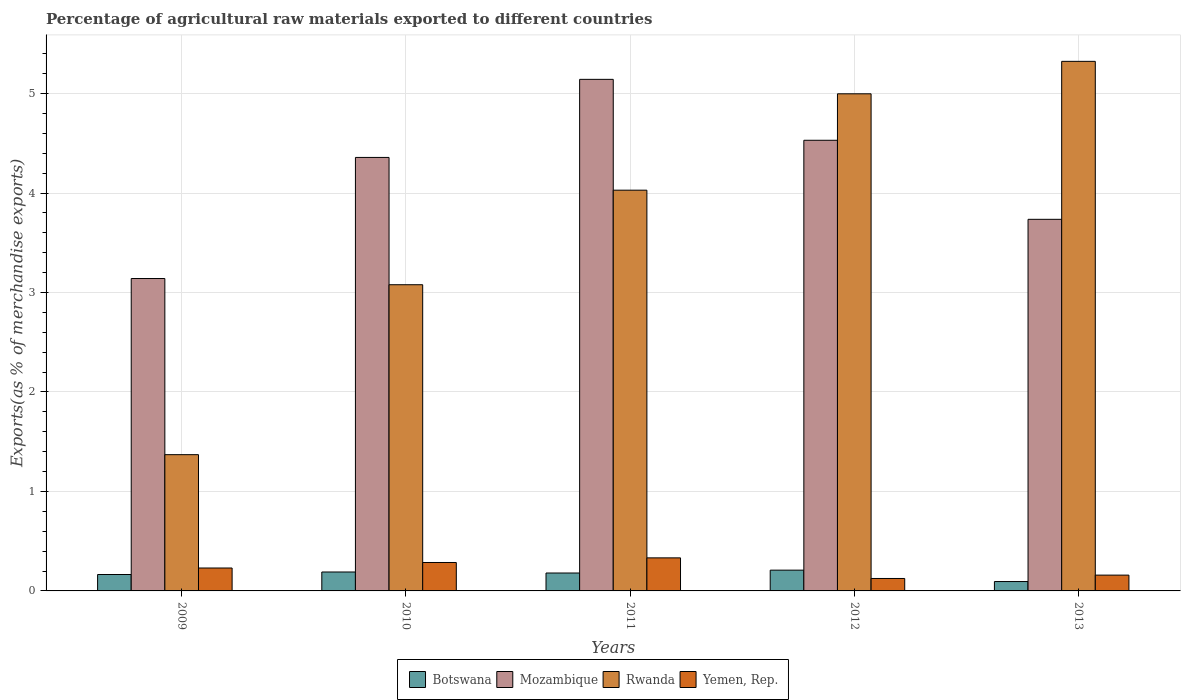Are the number of bars per tick equal to the number of legend labels?
Your answer should be very brief. Yes. Are the number of bars on each tick of the X-axis equal?
Offer a very short reply. Yes. How many bars are there on the 4th tick from the right?
Offer a very short reply. 4. What is the percentage of exports to different countries in Rwanda in 2013?
Give a very brief answer. 5.32. Across all years, what is the maximum percentage of exports to different countries in Botswana?
Offer a very short reply. 0.21. Across all years, what is the minimum percentage of exports to different countries in Botswana?
Make the answer very short. 0.09. In which year was the percentage of exports to different countries in Yemen, Rep. minimum?
Keep it short and to the point. 2012. What is the total percentage of exports to different countries in Mozambique in the graph?
Provide a succinct answer. 20.91. What is the difference between the percentage of exports to different countries in Yemen, Rep. in 2009 and that in 2013?
Offer a terse response. 0.07. What is the difference between the percentage of exports to different countries in Botswana in 2011 and the percentage of exports to different countries in Mozambique in 2012?
Provide a short and direct response. -4.35. What is the average percentage of exports to different countries in Botswana per year?
Your response must be concise. 0.17. In the year 2009, what is the difference between the percentage of exports to different countries in Yemen, Rep. and percentage of exports to different countries in Botswana?
Offer a terse response. 0.07. In how many years, is the percentage of exports to different countries in Mozambique greater than 3.8 %?
Provide a succinct answer. 3. What is the ratio of the percentage of exports to different countries in Mozambique in 2009 to that in 2010?
Offer a very short reply. 0.72. Is the difference between the percentage of exports to different countries in Yemen, Rep. in 2010 and 2011 greater than the difference between the percentage of exports to different countries in Botswana in 2010 and 2011?
Ensure brevity in your answer.  No. What is the difference between the highest and the second highest percentage of exports to different countries in Botswana?
Provide a short and direct response. 0.02. What is the difference between the highest and the lowest percentage of exports to different countries in Yemen, Rep.?
Offer a terse response. 0.21. In how many years, is the percentage of exports to different countries in Rwanda greater than the average percentage of exports to different countries in Rwanda taken over all years?
Provide a succinct answer. 3. Is it the case that in every year, the sum of the percentage of exports to different countries in Rwanda and percentage of exports to different countries in Mozambique is greater than the sum of percentage of exports to different countries in Yemen, Rep. and percentage of exports to different countries in Botswana?
Your answer should be compact. Yes. What does the 3rd bar from the left in 2009 represents?
Your answer should be very brief. Rwanda. What does the 3rd bar from the right in 2009 represents?
Offer a terse response. Mozambique. How many bars are there?
Give a very brief answer. 20. How many years are there in the graph?
Ensure brevity in your answer.  5. What is the difference between two consecutive major ticks on the Y-axis?
Provide a succinct answer. 1. Are the values on the major ticks of Y-axis written in scientific E-notation?
Offer a terse response. No. Does the graph contain any zero values?
Make the answer very short. No. Where does the legend appear in the graph?
Give a very brief answer. Bottom center. How many legend labels are there?
Your response must be concise. 4. How are the legend labels stacked?
Give a very brief answer. Horizontal. What is the title of the graph?
Your answer should be compact. Percentage of agricultural raw materials exported to different countries. Does "Tonga" appear as one of the legend labels in the graph?
Provide a short and direct response. No. What is the label or title of the X-axis?
Give a very brief answer. Years. What is the label or title of the Y-axis?
Offer a terse response. Exports(as % of merchandise exports). What is the Exports(as % of merchandise exports) of Botswana in 2009?
Provide a succinct answer. 0.17. What is the Exports(as % of merchandise exports) in Mozambique in 2009?
Provide a short and direct response. 3.14. What is the Exports(as % of merchandise exports) of Rwanda in 2009?
Your response must be concise. 1.37. What is the Exports(as % of merchandise exports) in Yemen, Rep. in 2009?
Offer a very short reply. 0.23. What is the Exports(as % of merchandise exports) of Botswana in 2010?
Ensure brevity in your answer.  0.19. What is the Exports(as % of merchandise exports) in Mozambique in 2010?
Provide a succinct answer. 4.36. What is the Exports(as % of merchandise exports) of Rwanda in 2010?
Offer a terse response. 3.08. What is the Exports(as % of merchandise exports) of Yemen, Rep. in 2010?
Provide a succinct answer. 0.29. What is the Exports(as % of merchandise exports) of Botswana in 2011?
Keep it short and to the point. 0.18. What is the Exports(as % of merchandise exports) of Mozambique in 2011?
Provide a short and direct response. 5.14. What is the Exports(as % of merchandise exports) in Rwanda in 2011?
Offer a terse response. 4.03. What is the Exports(as % of merchandise exports) of Yemen, Rep. in 2011?
Provide a succinct answer. 0.33. What is the Exports(as % of merchandise exports) in Botswana in 2012?
Provide a succinct answer. 0.21. What is the Exports(as % of merchandise exports) of Mozambique in 2012?
Ensure brevity in your answer.  4.53. What is the Exports(as % of merchandise exports) of Rwanda in 2012?
Make the answer very short. 5. What is the Exports(as % of merchandise exports) in Yemen, Rep. in 2012?
Make the answer very short. 0.13. What is the Exports(as % of merchandise exports) of Botswana in 2013?
Keep it short and to the point. 0.09. What is the Exports(as % of merchandise exports) in Mozambique in 2013?
Offer a terse response. 3.74. What is the Exports(as % of merchandise exports) in Rwanda in 2013?
Your answer should be compact. 5.32. What is the Exports(as % of merchandise exports) in Yemen, Rep. in 2013?
Provide a succinct answer. 0.16. Across all years, what is the maximum Exports(as % of merchandise exports) in Botswana?
Ensure brevity in your answer.  0.21. Across all years, what is the maximum Exports(as % of merchandise exports) of Mozambique?
Give a very brief answer. 5.14. Across all years, what is the maximum Exports(as % of merchandise exports) of Rwanda?
Provide a succinct answer. 5.32. Across all years, what is the maximum Exports(as % of merchandise exports) of Yemen, Rep.?
Provide a short and direct response. 0.33. Across all years, what is the minimum Exports(as % of merchandise exports) in Botswana?
Give a very brief answer. 0.09. Across all years, what is the minimum Exports(as % of merchandise exports) of Mozambique?
Make the answer very short. 3.14. Across all years, what is the minimum Exports(as % of merchandise exports) in Rwanda?
Keep it short and to the point. 1.37. Across all years, what is the minimum Exports(as % of merchandise exports) of Yemen, Rep.?
Offer a very short reply. 0.13. What is the total Exports(as % of merchandise exports) of Botswana in the graph?
Provide a short and direct response. 0.84. What is the total Exports(as % of merchandise exports) of Mozambique in the graph?
Your response must be concise. 20.91. What is the total Exports(as % of merchandise exports) of Rwanda in the graph?
Provide a succinct answer. 18.8. What is the total Exports(as % of merchandise exports) of Yemen, Rep. in the graph?
Provide a succinct answer. 1.13. What is the difference between the Exports(as % of merchandise exports) of Botswana in 2009 and that in 2010?
Ensure brevity in your answer.  -0.03. What is the difference between the Exports(as % of merchandise exports) in Mozambique in 2009 and that in 2010?
Ensure brevity in your answer.  -1.22. What is the difference between the Exports(as % of merchandise exports) of Rwanda in 2009 and that in 2010?
Offer a terse response. -1.71. What is the difference between the Exports(as % of merchandise exports) in Yemen, Rep. in 2009 and that in 2010?
Offer a very short reply. -0.06. What is the difference between the Exports(as % of merchandise exports) of Botswana in 2009 and that in 2011?
Make the answer very short. -0.02. What is the difference between the Exports(as % of merchandise exports) in Mozambique in 2009 and that in 2011?
Keep it short and to the point. -2. What is the difference between the Exports(as % of merchandise exports) in Rwanda in 2009 and that in 2011?
Provide a short and direct response. -2.66. What is the difference between the Exports(as % of merchandise exports) of Yemen, Rep. in 2009 and that in 2011?
Your answer should be compact. -0.1. What is the difference between the Exports(as % of merchandise exports) in Botswana in 2009 and that in 2012?
Your response must be concise. -0.04. What is the difference between the Exports(as % of merchandise exports) of Mozambique in 2009 and that in 2012?
Ensure brevity in your answer.  -1.39. What is the difference between the Exports(as % of merchandise exports) of Rwanda in 2009 and that in 2012?
Provide a short and direct response. -3.63. What is the difference between the Exports(as % of merchandise exports) in Yemen, Rep. in 2009 and that in 2012?
Give a very brief answer. 0.11. What is the difference between the Exports(as % of merchandise exports) in Botswana in 2009 and that in 2013?
Your answer should be very brief. 0.07. What is the difference between the Exports(as % of merchandise exports) in Mozambique in 2009 and that in 2013?
Keep it short and to the point. -0.6. What is the difference between the Exports(as % of merchandise exports) of Rwanda in 2009 and that in 2013?
Make the answer very short. -3.95. What is the difference between the Exports(as % of merchandise exports) in Yemen, Rep. in 2009 and that in 2013?
Provide a succinct answer. 0.07. What is the difference between the Exports(as % of merchandise exports) of Botswana in 2010 and that in 2011?
Make the answer very short. 0.01. What is the difference between the Exports(as % of merchandise exports) in Mozambique in 2010 and that in 2011?
Your answer should be compact. -0.79. What is the difference between the Exports(as % of merchandise exports) of Rwanda in 2010 and that in 2011?
Your response must be concise. -0.95. What is the difference between the Exports(as % of merchandise exports) in Yemen, Rep. in 2010 and that in 2011?
Provide a succinct answer. -0.05. What is the difference between the Exports(as % of merchandise exports) in Botswana in 2010 and that in 2012?
Offer a very short reply. -0.02. What is the difference between the Exports(as % of merchandise exports) of Mozambique in 2010 and that in 2012?
Offer a very short reply. -0.17. What is the difference between the Exports(as % of merchandise exports) in Rwanda in 2010 and that in 2012?
Ensure brevity in your answer.  -1.92. What is the difference between the Exports(as % of merchandise exports) in Yemen, Rep. in 2010 and that in 2012?
Provide a succinct answer. 0.16. What is the difference between the Exports(as % of merchandise exports) of Botswana in 2010 and that in 2013?
Offer a very short reply. 0.1. What is the difference between the Exports(as % of merchandise exports) in Mozambique in 2010 and that in 2013?
Make the answer very short. 0.62. What is the difference between the Exports(as % of merchandise exports) in Rwanda in 2010 and that in 2013?
Make the answer very short. -2.25. What is the difference between the Exports(as % of merchandise exports) in Yemen, Rep. in 2010 and that in 2013?
Your answer should be very brief. 0.13. What is the difference between the Exports(as % of merchandise exports) of Botswana in 2011 and that in 2012?
Offer a terse response. -0.03. What is the difference between the Exports(as % of merchandise exports) in Mozambique in 2011 and that in 2012?
Your answer should be very brief. 0.61. What is the difference between the Exports(as % of merchandise exports) in Rwanda in 2011 and that in 2012?
Offer a terse response. -0.97. What is the difference between the Exports(as % of merchandise exports) in Yemen, Rep. in 2011 and that in 2012?
Your answer should be compact. 0.21. What is the difference between the Exports(as % of merchandise exports) in Botswana in 2011 and that in 2013?
Provide a succinct answer. 0.09. What is the difference between the Exports(as % of merchandise exports) in Mozambique in 2011 and that in 2013?
Offer a very short reply. 1.41. What is the difference between the Exports(as % of merchandise exports) of Rwanda in 2011 and that in 2013?
Keep it short and to the point. -1.3. What is the difference between the Exports(as % of merchandise exports) in Yemen, Rep. in 2011 and that in 2013?
Your answer should be compact. 0.17. What is the difference between the Exports(as % of merchandise exports) of Botswana in 2012 and that in 2013?
Keep it short and to the point. 0.11. What is the difference between the Exports(as % of merchandise exports) in Mozambique in 2012 and that in 2013?
Provide a succinct answer. 0.79. What is the difference between the Exports(as % of merchandise exports) of Rwanda in 2012 and that in 2013?
Offer a terse response. -0.33. What is the difference between the Exports(as % of merchandise exports) in Yemen, Rep. in 2012 and that in 2013?
Offer a very short reply. -0.03. What is the difference between the Exports(as % of merchandise exports) in Botswana in 2009 and the Exports(as % of merchandise exports) in Mozambique in 2010?
Ensure brevity in your answer.  -4.19. What is the difference between the Exports(as % of merchandise exports) of Botswana in 2009 and the Exports(as % of merchandise exports) of Rwanda in 2010?
Your answer should be compact. -2.91. What is the difference between the Exports(as % of merchandise exports) of Botswana in 2009 and the Exports(as % of merchandise exports) of Yemen, Rep. in 2010?
Your response must be concise. -0.12. What is the difference between the Exports(as % of merchandise exports) in Mozambique in 2009 and the Exports(as % of merchandise exports) in Rwanda in 2010?
Give a very brief answer. 0.06. What is the difference between the Exports(as % of merchandise exports) of Mozambique in 2009 and the Exports(as % of merchandise exports) of Yemen, Rep. in 2010?
Provide a short and direct response. 2.85. What is the difference between the Exports(as % of merchandise exports) of Rwanda in 2009 and the Exports(as % of merchandise exports) of Yemen, Rep. in 2010?
Offer a terse response. 1.08. What is the difference between the Exports(as % of merchandise exports) of Botswana in 2009 and the Exports(as % of merchandise exports) of Mozambique in 2011?
Ensure brevity in your answer.  -4.98. What is the difference between the Exports(as % of merchandise exports) in Botswana in 2009 and the Exports(as % of merchandise exports) in Rwanda in 2011?
Provide a short and direct response. -3.86. What is the difference between the Exports(as % of merchandise exports) of Botswana in 2009 and the Exports(as % of merchandise exports) of Yemen, Rep. in 2011?
Your answer should be compact. -0.17. What is the difference between the Exports(as % of merchandise exports) in Mozambique in 2009 and the Exports(as % of merchandise exports) in Rwanda in 2011?
Provide a short and direct response. -0.89. What is the difference between the Exports(as % of merchandise exports) in Mozambique in 2009 and the Exports(as % of merchandise exports) in Yemen, Rep. in 2011?
Your answer should be compact. 2.81. What is the difference between the Exports(as % of merchandise exports) in Rwanda in 2009 and the Exports(as % of merchandise exports) in Yemen, Rep. in 2011?
Make the answer very short. 1.04. What is the difference between the Exports(as % of merchandise exports) of Botswana in 2009 and the Exports(as % of merchandise exports) of Mozambique in 2012?
Your answer should be very brief. -4.37. What is the difference between the Exports(as % of merchandise exports) of Botswana in 2009 and the Exports(as % of merchandise exports) of Rwanda in 2012?
Your response must be concise. -4.83. What is the difference between the Exports(as % of merchandise exports) of Botswana in 2009 and the Exports(as % of merchandise exports) of Yemen, Rep. in 2012?
Your answer should be very brief. 0.04. What is the difference between the Exports(as % of merchandise exports) in Mozambique in 2009 and the Exports(as % of merchandise exports) in Rwanda in 2012?
Offer a very short reply. -1.86. What is the difference between the Exports(as % of merchandise exports) of Mozambique in 2009 and the Exports(as % of merchandise exports) of Yemen, Rep. in 2012?
Provide a succinct answer. 3.02. What is the difference between the Exports(as % of merchandise exports) in Rwanda in 2009 and the Exports(as % of merchandise exports) in Yemen, Rep. in 2012?
Ensure brevity in your answer.  1.24. What is the difference between the Exports(as % of merchandise exports) of Botswana in 2009 and the Exports(as % of merchandise exports) of Mozambique in 2013?
Your answer should be compact. -3.57. What is the difference between the Exports(as % of merchandise exports) of Botswana in 2009 and the Exports(as % of merchandise exports) of Rwanda in 2013?
Offer a very short reply. -5.16. What is the difference between the Exports(as % of merchandise exports) of Botswana in 2009 and the Exports(as % of merchandise exports) of Yemen, Rep. in 2013?
Keep it short and to the point. 0.01. What is the difference between the Exports(as % of merchandise exports) in Mozambique in 2009 and the Exports(as % of merchandise exports) in Rwanda in 2013?
Your answer should be compact. -2.18. What is the difference between the Exports(as % of merchandise exports) in Mozambique in 2009 and the Exports(as % of merchandise exports) in Yemen, Rep. in 2013?
Provide a succinct answer. 2.98. What is the difference between the Exports(as % of merchandise exports) in Rwanda in 2009 and the Exports(as % of merchandise exports) in Yemen, Rep. in 2013?
Keep it short and to the point. 1.21. What is the difference between the Exports(as % of merchandise exports) in Botswana in 2010 and the Exports(as % of merchandise exports) in Mozambique in 2011?
Your response must be concise. -4.95. What is the difference between the Exports(as % of merchandise exports) of Botswana in 2010 and the Exports(as % of merchandise exports) of Rwanda in 2011?
Provide a short and direct response. -3.84. What is the difference between the Exports(as % of merchandise exports) in Botswana in 2010 and the Exports(as % of merchandise exports) in Yemen, Rep. in 2011?
Keep it short and to the point. -0.14. What is the difference between the Exports(as % of merchandise exports) of Mozambique in 2010 and the Exports(as % of merchandise exports) of Rwanda in 2011?
Offer a terse response. 0.33. What is the difference between the Exports(as % of merchandise exports) of Mozambique in 2010 and the Exports(as % of merchandise exports) of Yemen, Rep. in 2011?
Offer a very short reply. 4.03. What is the difference between the Exports(as % of merchandise exports) in Rwanda in 2010 and the Exports(as % of merchandise exports) in Yemen, Rep. in 2011?
Provide a short and direct response. 2.75. What is the difference between the Exports(as % of merchandise exports) in Botswana in 2010 and the Exports(as % of merchandise exports) in Mozambique in 2012?
Your answer should be compact. -4.34. What is the difference between the Exports(as % of merchandise exports) of Botswana in 2010 and the Exports(as % of merchandise exports) of Rwanda in 2012?
Your answer should be very brief. -4.81. What is the difference between the Exports(as % of merchandise exports) in Botswana in 2010 and the Exports(as % of merchandise exports) in Yemen, Rep. in 2012?
Make the answer very short. 0.07. What is the difference between the Exports(as % of merchandise exports) in Mozambique in 2010 and the Exports(as % of merchandise exports) in Rwanda in 2012?
Make the answer very short. -0.64. What is the difference between the Exports(as % of merchandise exports) of Mozambique in 2010 and the Exports(as % of merchandise exports) of Yemen, Rep. in 2012?
Provide a short and direct response. 4.23. What is the difference between the Exports(as % of merchandise exports) of Rwanda in 2010 and the Exports(as % of merchandise exports) of Yemen, Rep. in 2012?
Ensure brevity in your answer.  2.95. What is the difference between the Exports(as % of merchandise exports) in Botswana in 2010 and the Exports(as % of merchandise exports) in Mozambique in 2013?
Ensure brevity in your answer.  -3.55. What is the difference between the Exports(as % of merchandise exports) in Botswana in 2010 and the Exports(as % of merchandise exports) in Rwanda in 2013?
Make the answer very short. -5.13. What is the difference between the Exports(as % of merchandise exports) in Botswana in 2010 and the Exports(as % of merchandise exports) in Yemen, Rep. in 2013?
Keep it short and to the point. 0.03. What is the difference between the Exports(as % of merchandise exports) in Mozambique in 2010 and the Exports(as % of merchandise exports) in Rwanda in 2013?
Offer a very short reply. -0.97. What is the difference between the Exports(as % of merchandise exports) of Mozambique in 2010 and the Exports(as % of merchandise exports) of Yemen, Rep. in 2013?
Keep it short and to the point. 4.2. What is the difference between the Exports(as % of merchandise exports) in Rwanda in 2010 and the Exports(as % of merchandise exports) in Yemen, Rep. in 2013?
Your answer should be very brief. 2.92. What is the difference between the Exports(as % of merchandise exports) of Botswana in 2011 and the Exports(as % of merchandise exports) of Mozambique in 2012?
Ensure brevity in your answer.  -4.35. What is the difference between the Exports(as % of merchandise exports) of Botswana in 2011 and the Exports(as % of merchandise exports) of Rwanda in 2012?
Your answer should be compact. -4.82. What is the difference between the Exports(as % of merchandise exports) of Botswana in 2011 and the Exports(as % of merchandise exports) of Yemen, Rep. in 2012?
Your answer should be compact. 0.06. What is the difference between the Exports(as % of merchandise exports) of Mozambique in 2011 and the Exports(as % of merchandise exports) of Rwanda in 2012?
Give a very brief answer. 0.15. What is the difference between the Exports(as % of merchandise exports) in Mozambique in 2011 and the Exports(as % of merchandise exports) in Yemen, Rep. in 2012?
Keep it short and to the point. 5.02. What is the difference between the Exports(as % of merchandise exports) in Rwanda in 2011 and the Exports(as % of merchandise exports) in Yemen, Rep. in 2012?
Give a very brief answer. 3.9. What is the difference between the Exports(as % of merchandise exports) in Botswana in 2011 and the Exports(as % of merchandise exports) in Mozambique in 2013?
Offer a terse response. -3.56. What is the difference between the Exports(as % of merchandise exports) of Botswana in 2011 and the Exports(as % of merchandise exports) of Rwanda in 2013?
Ensure brevity in your answer.  -5.14. What is the difference between the Exports(as % of merchandise exports) in Botswana in 2011 and the Exports(as % of merchandise exports) in Yemen, Rep. in 2013?
Offer a terse response. 0.02. What is the difference between the Exports(as % of merchandise exports) of Mozambique in 2011 and the Exports(as % of merchandise exports) of Rwanda in 2013?
Keep it short and to the point. -0.18. What is the difference between the Exports(as % of merchandise exports) in Mozambique in 2011 and the Exports(as % of merchandise exports) in Yemen, Rep. in 2013?
Offer a terse response. 4.98. What is the difference between the Exports(as % of merchandise exports) of Rwanda in 2011 and the Exports(as % of merchandise exports) of Yemen, Rep. in 2013?
Ensure brevity in your answer.  3.87. What is the difference between the Exports(as % of merchandise exports) in Botswana in 2012 and the Exports(as % of merchandise exports) in Mozambique in 2013?
Make the answer very short. -3.53. What is the difference between the Exports(as % of merchandise exports) of Botswana in 2012 and the Exports(as % of merchandise exports) of Rwanda in 2013?
Make the answer very short. -5.12. What is the difference between the Exports(as % of merchandise exports) in Botswana in 2012 and the Exports(as % of merchandise exports) in Yemen, Rep. in 2013?
Ensure brevity in your answer.  0.05. What is the difference between the Exports(as % of merchandise exports) in Mozambique in 2012 and the Exports(as % of merchandise exports) in Rwanda in 2013?
Your answer should be compact. -0.79. What is the difference between the Exports(as % of merchandise exports) of Mozambique in 2012 and the Exports(as % of merchandise exports) of Yemen, Rep. in 2013?
Your response must be concise. 4.37. What is the difference between the Exports(as % of merchandise exports) of Rwanda in 2012 and the Exports(as % of merchandise exports) of Yemen, Rep. in 2013?
Your answer should be very brief. 4.84. What is the average Exports(as % of merchandise exports) in Botswana per year?
Your response must be concise. 0.17. What is the average Exports(as % of merchandise exports) in Mozambique per year?
Ensure brevity in your answer.  4.18. What is the average Exports(as % of merchandise exports) in Rwanda per year?
Give a very brief answer. 3.76. What is the average Exports(as % of merchandise exports) in Yemen, Rep. per year?
Provide a succinct answer. 0.23. In the year 2009, what is the difference between the Exports(as % of merchandise exports) of Botswana and Exports(as % of merchandise exports) of Mozambique?
Ensure brevity in your answer.  -2.98. In the year 2009, what is the difference between the Exports(as % of merchandise exports) in Botswana and Exports(as % of merchandise exports) in Rwanda?
Your response must be concise. -1.2. In the year 2009, what is the difference between the Exports(as % of merchandise exports) in Botswana and Exports(as % of merchandise exports) in Yemen, Rep.?
Keep it short and to the point. -0.07. In the year 2009, what is the difference between the Exports(as % of merchandise exports) in Mozambique and Exports(as % of merchandise exports) in Rwanda?
Your answer should be very brief. 1.77. In the year 2009, what is the difference between the Exports(as % of merchandise exports) of Mozambique and Exports(as % of merchandise exports) of Yemen, Rep.?
Your response must be concise. 2.91. In the year 2009, what is the difference between the Exports(as % of merchandise exports) in Rwanda and Exports(as % of merchandise exports) in Yemen, Rep.?
Your response must be concise. 1.14. In the year 2010, what is the difference between the Exports(as % of merchandise exports) in Botswana and Exports(as % of merchandise exports) in Mozambique?
Provide a succinct answer. -4.17. In the year 2010, what is the difference between the Exports(as % of merchandise exports) of Botswana and Exports(as % of merchandise exports) of Rwanda?
Offer a terse response. -2.89. In the year 2010, what is the difference between the Exports(as % of merchandise exports) of Botswana and Exports(as % of merchandise exports) of Yemen, Rep.?
Make the answer very short. -0.1. In the year 2010, what is the difference between the Exports(as % of merchandise exports) of Mozambique and Exports(as % of merchandise exports) of Rwanda?
Ensure brevity in your answer.  1.28. In the year 2010, what is the difference between the Exports(as % of merchandise exports) in Mozambique and Exports(as % of merchandise exports) in Yemen, Rep.?
Your answer should be very brief. 4.07. In the year 2010, what is the difference between the Exports(as % of merchandise exports) of Rwanda and Exports(as % of merchandise exports) of Yemen, Rep.?
Your answer should be compact. 2.79. In the year 2011, what is the difference between the Exports(as % of merchandise exports) of Botswana and Exports(as % of merchandise exports) of Mozambique?
Your response must be concise. -4.96. In the year 2011, what is the difference between the Exports(as % of merchandise exports) in Botswana and Exports(as % of merchandise exports) in Rwanda?
Provide a succinct answer. -3.85. In the year 2011, what is the difference between the Exports(as % of merchandise exports) in Botswana and Exports(as % of merchandise exports) in Yemen, Rep.?
Provide a short and direct response. -0.15. In the year 2011, what is the difference between the Exports(as % of merchandise exports) of Mozambique and Exports(as % of merchandise exports) of Rwanda?
Make the answer very short. 1.11. In the year 2011, what is the difference between the Exports(as % of merchandise exports) of Mozambique and Exports(as % of merchandise exports) of Yemen, Rep.?
Your answer should be compact. 4.81. In the year 2011, what is the difference between the Exports(as % of merchandise exports) of Rwanda and Exports(as % of merchandise exports) of Yemen, Rep.?
Offer a terse response. 3.7. In the year 2012, what is the difference between the Exports(as % of merchandise exports) of Botswana and Exports(as % of merchandise exports) of Mozambique?
Make the answer very short. -4.32. In the year 2012, what is the difference between the Exports(as % of merchandise exports) of Botswana and Exports(as % of merchandise exports) of Rwanda?
Your answer should be compact. -4.79. In the year 2012, what is the difference between the Exports(as % of merchandise exports) in Botswana and Exports(as % of merchandise exports) in Yemen, Rep.?
Provide a succinct answer. 0.08. In the year 2012, what is the difference between the Exports(as % of merchandise exports) in Mozambique and Exports(as % of merchandise exports) in Rwanda?
Ensure brevity in your answer.  -0.47. In the year 2012, what is the difference between the Exports(as % of merchandise exports) in Mozambique and Exports(as % of merchandise exports) in Yemen, Rep.?
Keep it short and to the point. 4.41. In the year 2012, what is the difference between the Exports(as % of merchandise exports) of Rwanda and Exports(as % of merchandise exports) of Yemen, Rep.?
Give a very brief answer. 4.87. In the year 2013, what is the difference between the Exports(as % of merchandise exports) of Botswana and Exports(as % of merchandise exports) of Mozambique?
Offer a very short reply. -3.64. In the year 2013, what is the difference between the Exports(as % of merchandise exports) of Botswana and Exports(as % of merchandise exports) of Rwanda?
Offer a terse response. -5.23. In the year 2013, what is the difference between the Exports(as % of merchandise exports) of Botswana and Exports(as % of merchandise exports) of Yemen, Rep.?
Your answer should be compact. -0.06. In the year 2013, what is the difference between the Exports(as % of merchandise exports) in Mozambique and Exports(as % of merchandise exports) in Rwanda?
Give a very brief answer. -1.59. In the year 2013, what is the difference between the Exports(as % of merchandise exports) in Mozambique and Exports(as % of merchandise exports) in Yemen, Rep.?
Give a very brief answer. 3.58. In the year 2013, what is the difference between the Exports(as % of merchandise exports) of Rwanda and Exports(as % of merchandise exports) of Yemen, Rep.?
Ensure brevity in your answer.  5.17. What is the ratio of the Exports(as % of merchandise exports) of Botswana in 2009 to that in 2010?
Your answer should be very brief. 0.87. What is the ratio of the Exports(as % of merchandise exports) of Mozambique in 2009 to that in 2010?
Ensure brevity in your answer.  0.72. What is the ratio of the Exports(as % of merchandise exports) in Rwanda in 2009 to that in 2010?
Make the answer very short. 0.45. What is the ratio of the Exports(as % of merchandise exports) in Yemen, Rep. in 2009 to that in 2010?
Give a very brief answer. 0.81. What is the ratio of the Exports(as % of merchandise exports) in Botswana in 2009 to that in 2011?
Your answer should be very brief. 0.92. What is the ratio of the Exports(as % of merchandise exports) in Mozambique in 2009 to that in 2011?
Your answer should be compact. 0.61. What is the ratio of the Exports(as % of merchandise exports) in Rwanda in 2009 to that in 2011?
Offer a very short reply. 0.34. What is the ratio of the Exports(as % of merchandise exports) of Yemen, Rep. in 2009 to that in 2011?
Make the answer very short. 0.69. What is the ratio of the Exports(as % of merchandise exports) of Botswana in 2009 to that in 2012?
Offer a very short reply. 0.79. What is the ratio of the Exports(as % of merchandise exports) of Mozambique in 2009 to that in 2012?
Offer a terse response. 0.69. What is the ratio of the Exports(as % of merchandise exports) of Rwanda in 2009 to that in 2012?
Provide a succinct answer. 0.27. What is the ratio of the Exports(as % of merchandise exports) in Yemen, Rep. in 2009 to that in 2012?
Your answer should be compact. 1.84. What is the ratio of the Exports(as % of merchandise exports) of Botswana in 2009 to that in 2013?
Offer a terse response. 1.75. What is the ratio of the Exports(as % of merchandise exports) of Mozambique in 2009 to that in 2013?
Offer a terse response. 0.84. What is the ratio of the Exports(as % of merchandise exports) in Rwanda in 2009 to that in 2013?
Offer a terse response. 0.26. What is the ratio of the Exports(as % of merchandise exports) in Yemen, Rep. in 2009 to that in 2013?
Give a very brief answer. 1.45. What is the ratio of the Exports(as % of merchandise exports) in Botswana in 2010 to that in 2011?
Keep it short and to the point. 1.06. What is the ratio of the Exports(as % of merchandise exports) of Mozambique in 2010 to that in 2011?
Your response must be concise. 0.85. What is the ratio of the Exports(as % of merchandise exports) of Rwanda in 2010 to that in 2011?
Provide a succinct answer. 0.76. What is the ratio of the Exports(as % of merchandise exports) in Yemen, Rep. in 2010 to that in 2011?
Your response must be concise. 0.86. What is the ratio of the Exports(as % of merchandise exports) of Botswana in 2010 to that in 2012?
Your answer should be compact. 0.91. What is the ratio of the Exports(as % of merchandise exports) in Mozambique in 2010 to that in 2012?
Your response must be concise. 0.96. What is the ratio of the Exports(as % of merchandise exports) in Rwanda in 2010 to that in 2012?
Offer a terse response. 0.62. What is the ratio of the Exports(as % of merchandise exports) in Yemen, Rep. in 2010 to that in 2012?
Make the answer very short. 2.28. What is the ratio of the Exports(as % of merchandise exports) in Botswana in 2010 to that in 2013?
Your answer should be very brief. 2.02. What is the ratio of the Exports(as % of merchandise exports) of Mozambique in 2010 to that in 2013?
Keep it short and to the point. 1.17. What is the ratio of the Exports(as % of merchandise exports) in Rwanda in 2010 to that in 2013?
Offer a terse response. 0.58. What is the ratio of the Exports(as % of merchandise exports) in Yemen, Rep. in 2010 to that in 2013?
Make the answer very short. 1.8. What is the ratio of the Exports(as % of merchandise exports) in Botswana in 2011 to that in 2012?
Keep it short and to the point. 0.86. What is the ratio of the Exports(as % of merchandise exports) of Mozambique in 2011 to that in 2012?
Make the answer very short. 1.14. What is the ratio of the Exports(as % of merchandise exports) of Rwanda in 2011 to that in 2012?
Give a very brief answer. 0.81. What is the ratio of the Exports(as % of merchandise exports) of Yemen, Rep. in 2011 to that in 2012?
Your answer should be very brief. 2.65. What is the ratio of the Exports(as % of merchandise exports) in Botswana in 2011 to that in 2013?
Offer a terse response. 1.91. What is the ratio of the Exports(as % of merchandise exports) of Mozambique in 2011 to that in 2013?
Provide a succinct answer. 1.38. What is the ratio of the Exports(as % of merchandise exports) in Rwanda in 2011 to that in 2013?
Offer a very short reply. 0.76. What is the ratio of the Exports(as % of merchandise exports) of Yemen, Rep. in 2011 to that in 2013?
Make the answer very short. 2.09. What is the ratio of the Exports(as % of merchandise exports) in Botswana in 2012 to that in 2013?
Ensure brevity in your answer.  2.21. What is the ratio of the Exports(as % of merchandise exports) in Mozambique in 2012 to that in 2013?
Provide a succinct answer. 1.21. What is the ratio of the Exports(as % of merchandise exports) of Rwanda in 2012 to that in 2013?
Provide a succinct answer. 0.94. What is the ratio of the Exports(as % of merchandise exports) in Yemen, Rep. in 2012 to that in 2013?
Provide a succinct answer. 0.79. What is the difference between the highest and the second highest Exports(as % of merchandise exports) of Botswana?
Offer a very short reply. 0.02. What is the difference between the highest and the second highest Exports(as % of merchandise exports) in Mozambique?
Ensure brevity in your answer.  0.61. What is the difference between the highest and the second highest Exports(as % of merchandise exports) in Rwanda?
Make the answer very short. 0.33. What is the difference between the highest and the second highest Exports(as % of merchandise exports) in Yemen, Rep.?
Provide a short and direct response. 0.05. What is the difference between the highest and the lowest Exports(as % of merchandise exports) in Botswana?
Your answer should be compact. 0.11. What is the difference between the highest and the lowest Exports(as % of merchandise exports) of Mozambique?
Make the answer very short. 2. What is the difference between the highest and the lowest Exports(as % of merchandise exports) of Rwanda?
Your response must be concise. 3.95. What is the difference between the highest and the lowest Exports(as % of merchandise exports) of Yemen, Rep.?
Make the answer very short. 0.21. 